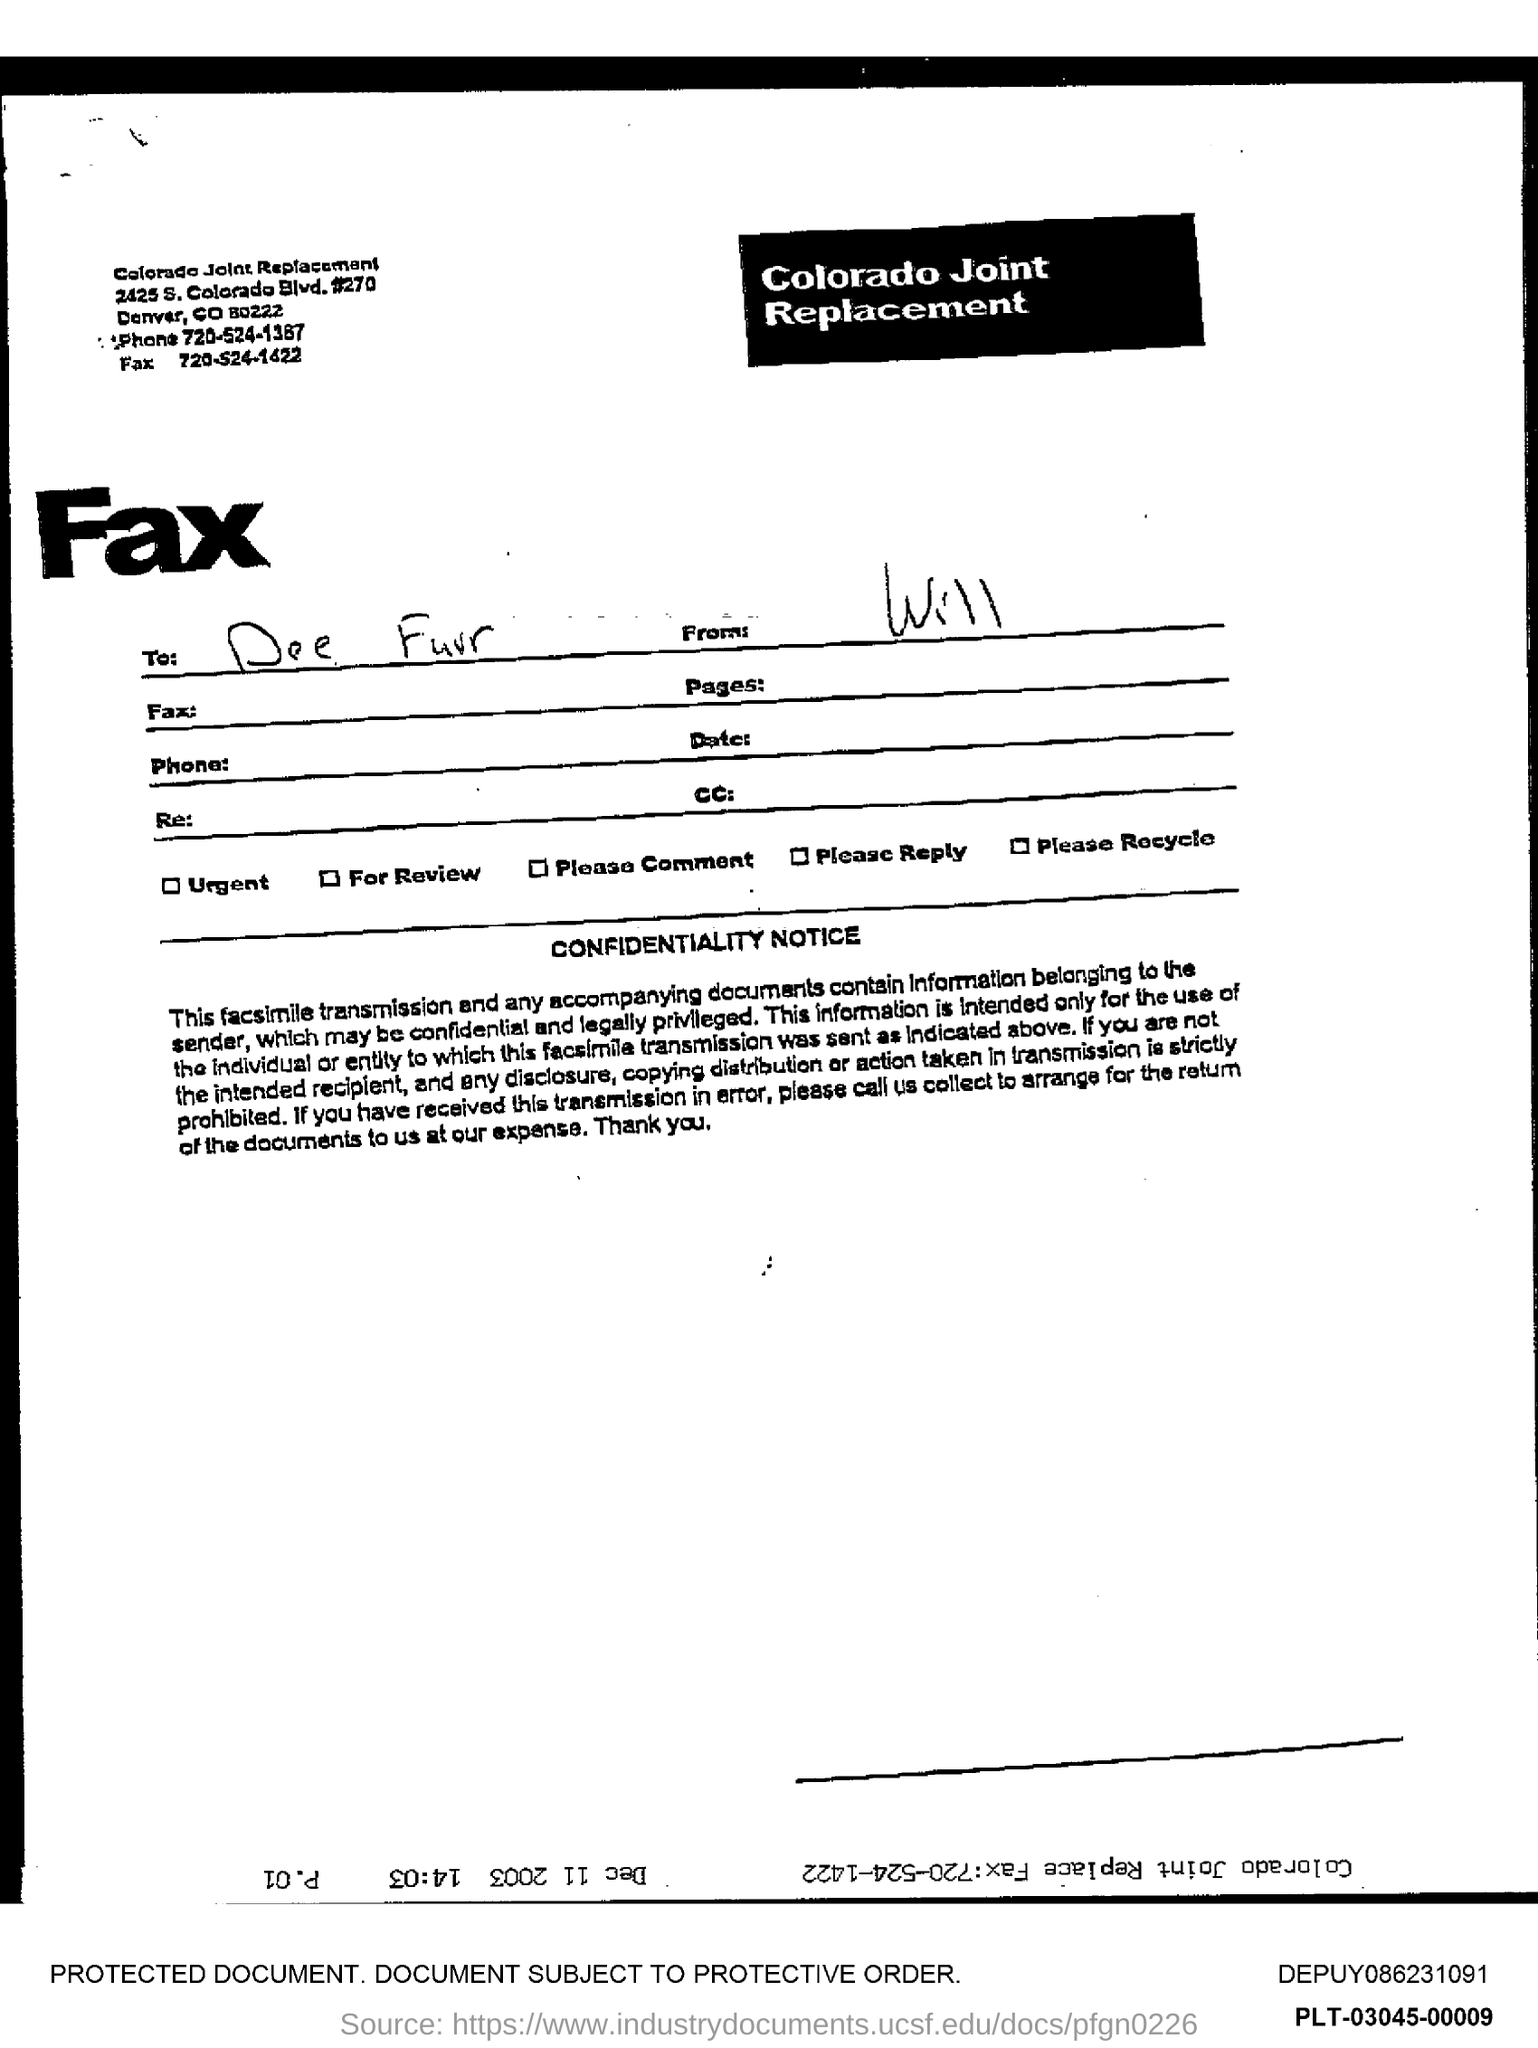What is the phone number mentioned in the document?
Your response must be concise. 720-524-1387. 